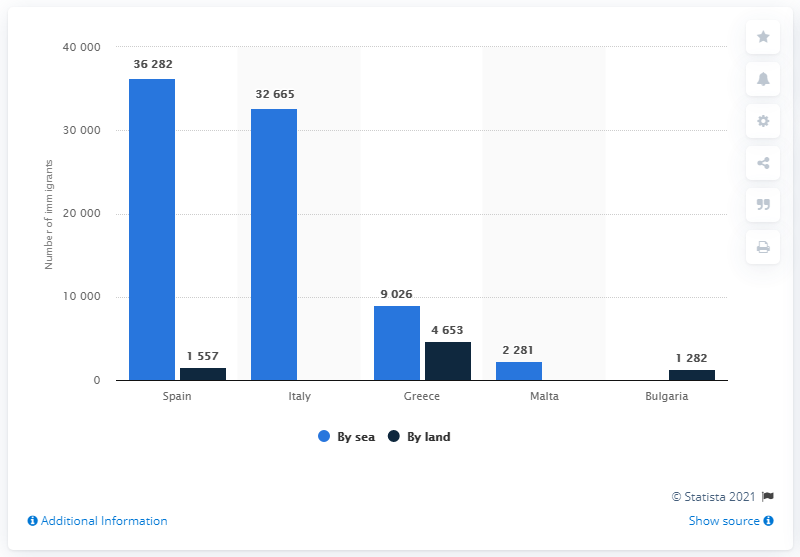Draw attention to some important aspects in this diagram. In 2020, the highest number of immigrants who arrived in Europe by land was recorded in [insert country name], with a total of [insert number]. As of December 3, 2020, 36,282 immigrants had reached Spain by sea. The difference between the shortest light blue bar and the tallest dark blue bar is 2372. 